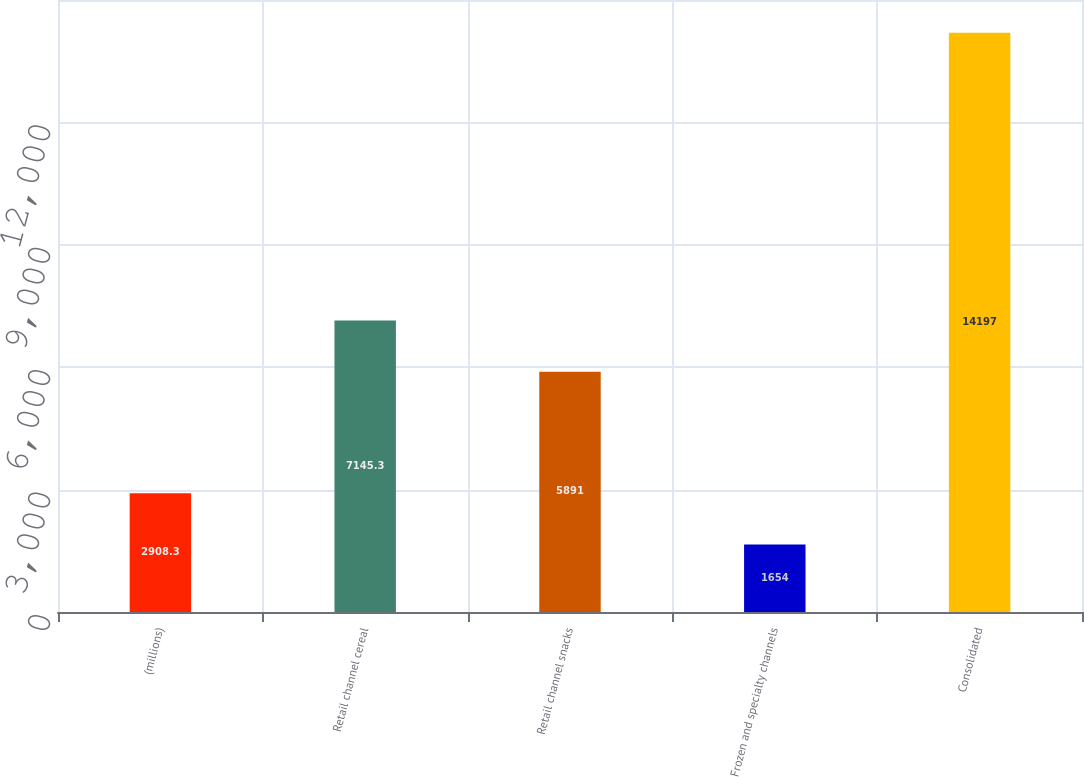<chart> <loc_0><loc_0><loc_500><loc_500><bar_chart><fcel>(millions)<fcel>Retail channel cereal<fcel>Retail channel snacks<fcel>Frozen and specialty channels<fcel>Consolidated<nl><fcel>2908.3<fcel>7145.3<fcel>5891<fcel>1654<fcel>14197<nl></chart> 